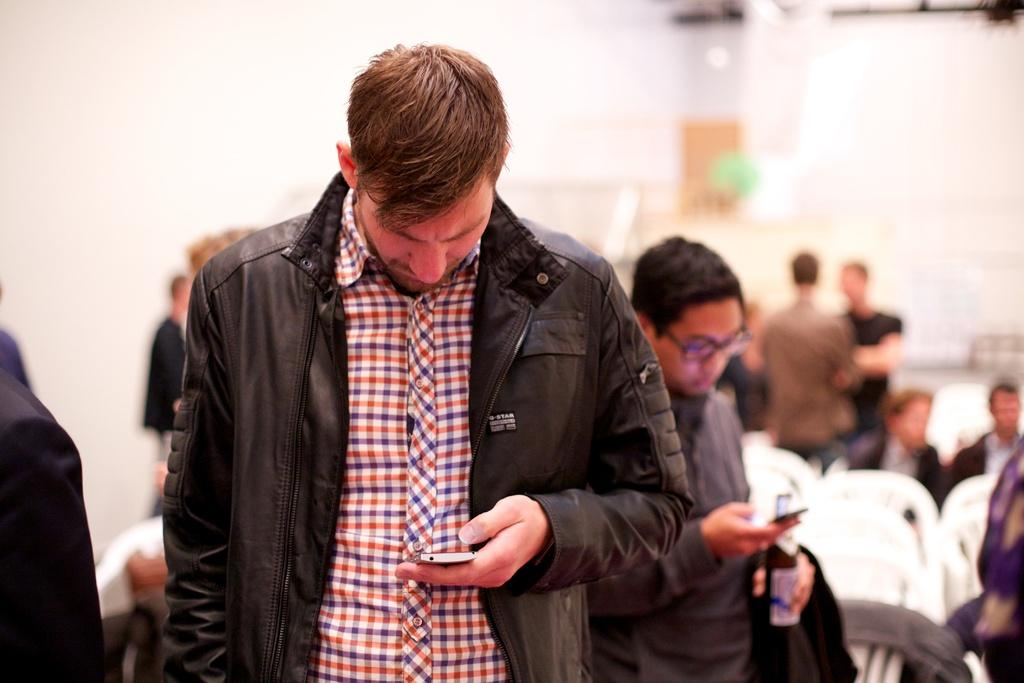What are the persons in the image doing? There are persons standing in the image, and some of them are holding a phone or a bottle. Are there any persons sitting in the image? Yes, there are persons sitting on chairs in the image. Can you describe the background of the image? The background appears blurry. Reasoning: Let'g: Let's think step by step in order to produce the conversation. We start by identifying the main subjects in the image, which are the persons standing and sitting. Then, we describe what they are doing, such as holding a phone or a bottle. Finally, we mention the background's appearance, which is blurry. Absurd Question/Answer: What type of drum can be heard playing in the background of the image? There is no drum or sound present in the image; it is a still image. How many minutes does it take for the hot water to cool down in the image? There is no hot water or indication of temperature in the image; it is a still image. 